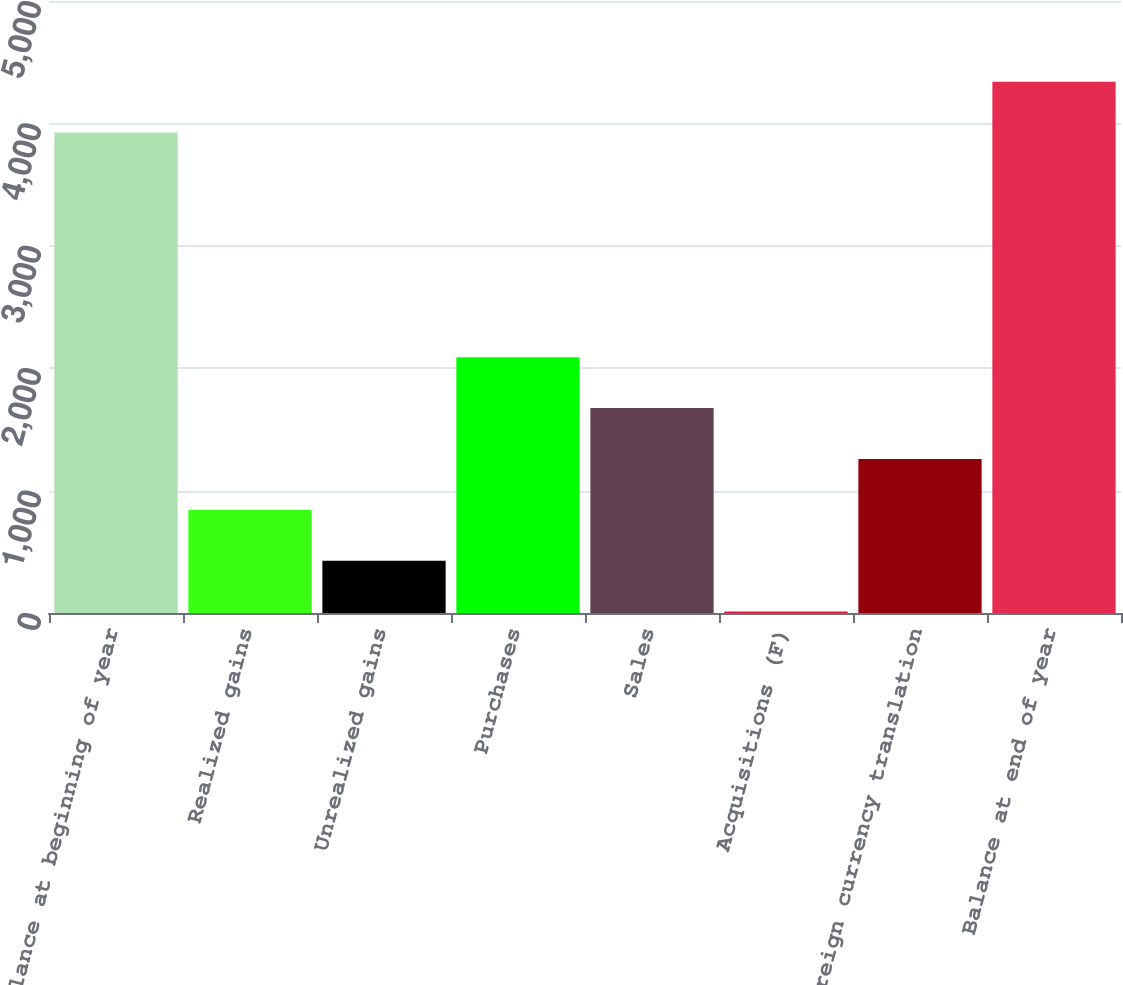<chart> <loc_0><loc_0><loc_500><loc_500><bar_chart><fcel>Balance at beginning of year<fcel>Realized gains<fcel>Unrealized gains<fcel>Purchases<fcel>Sales<fcel>Acquisitions (F)<fcel>Foreign currency translation<fcel>Balance at end of year<nl><fcel>3925<fcel>843.2<fcel>427.6<fcel>2090<fcel>1674.4<fcel>12<fcel>1258.8<fcel>4340.6<nl></chart> 